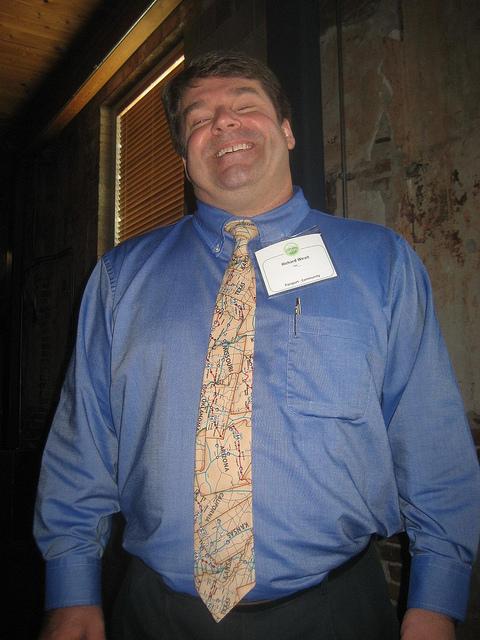Is the man happy?
Give a very brief answer. Yes. Is he too thin?
Concise answer only. No. Does he have black hair?
Keep it brief. No. What is his name?
Give a very brief answer. Steve. What color is the man's tie?
Quick response, please. Yellow. What is around the man's neck?
Give a very brief answer. Tie. 